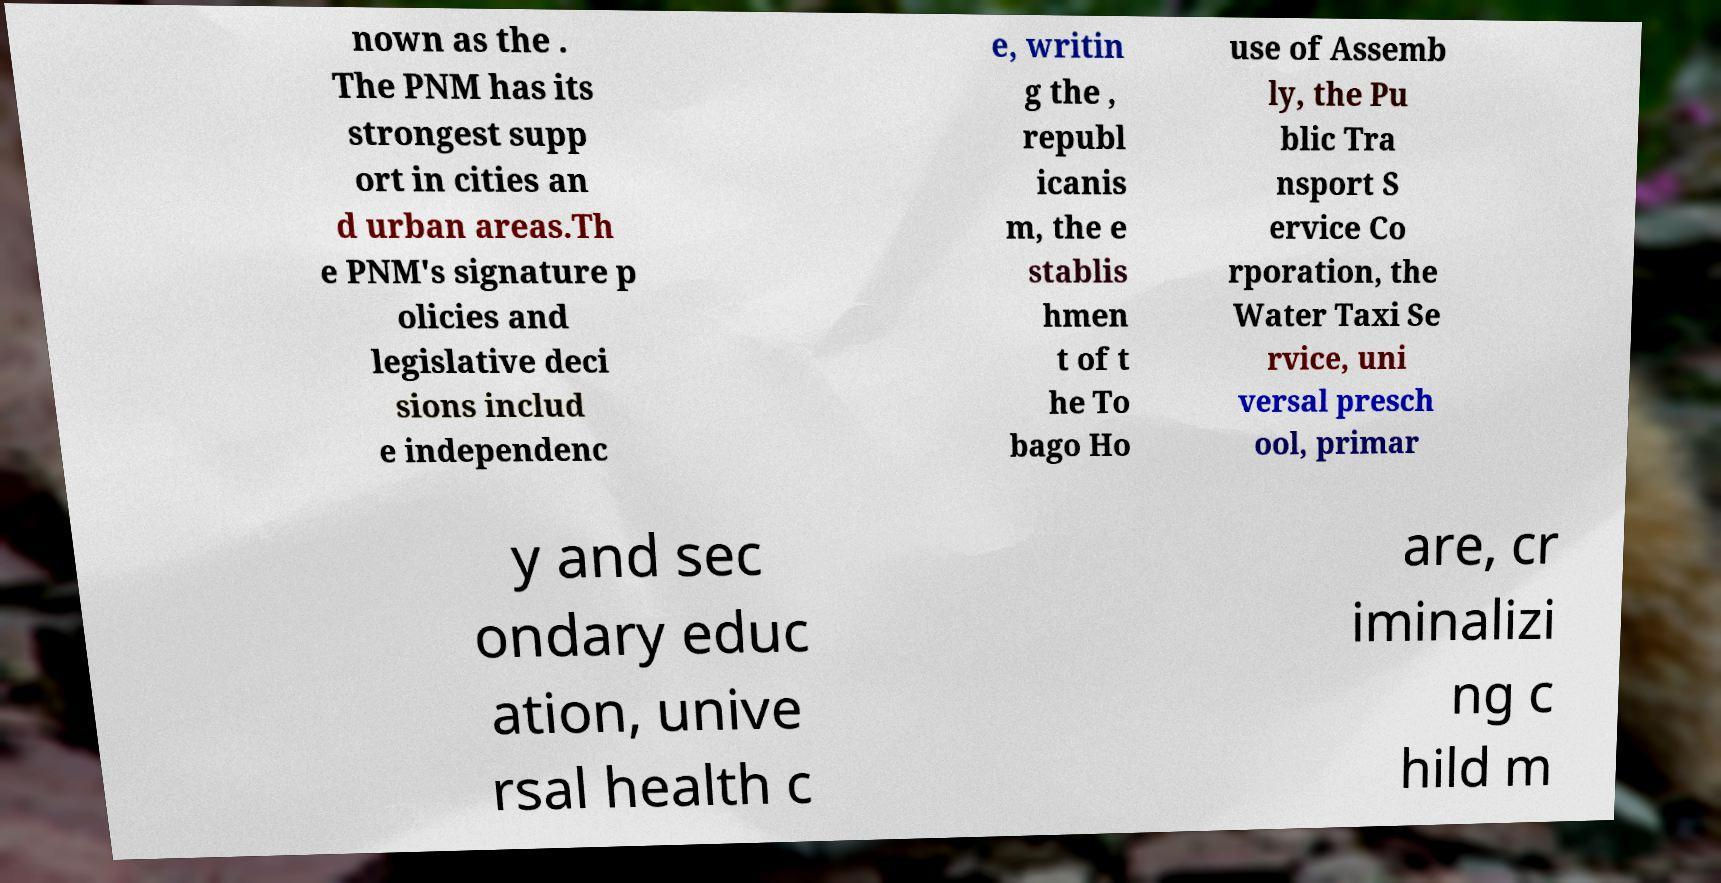There's text embedded in this image that I need extracted. Can you transcribe it verbatim? nown as the . The PNM has its strongest supp ort in cities an d urban areas.Th e PNM's signature p olicies and legislative deci sions includ e independenc e, writin g the , republ icanis m, the e stablis hmen t of t he To bago Ho use of Assemb ly, the Pu blic Tra nsport S ervice Co rporation, the Water Taxi Se rvice, uni versal presch ool, primar y and sec ondary educ ation, unive rsal health c are, cr iminalizi ng c hild m 